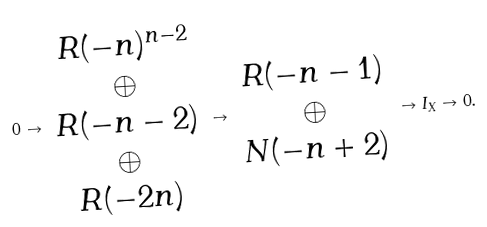Convert formula to latex. <formula><loc_0><loc_0><loc_500><loc_500>0 \to \begin{array} { c } R ( - n ) ^ { n - 2 } \\ \oplus \\ R ( - n - 2 ) \\ \oplus \\ R ( - 2 n ) \end{array} \to \begin{array} { c } R ( - n - 1 ) \\ \oplus \\ N ( - n + 2 ) \end{array} \to I _ { X } \to 0 .</formula> 